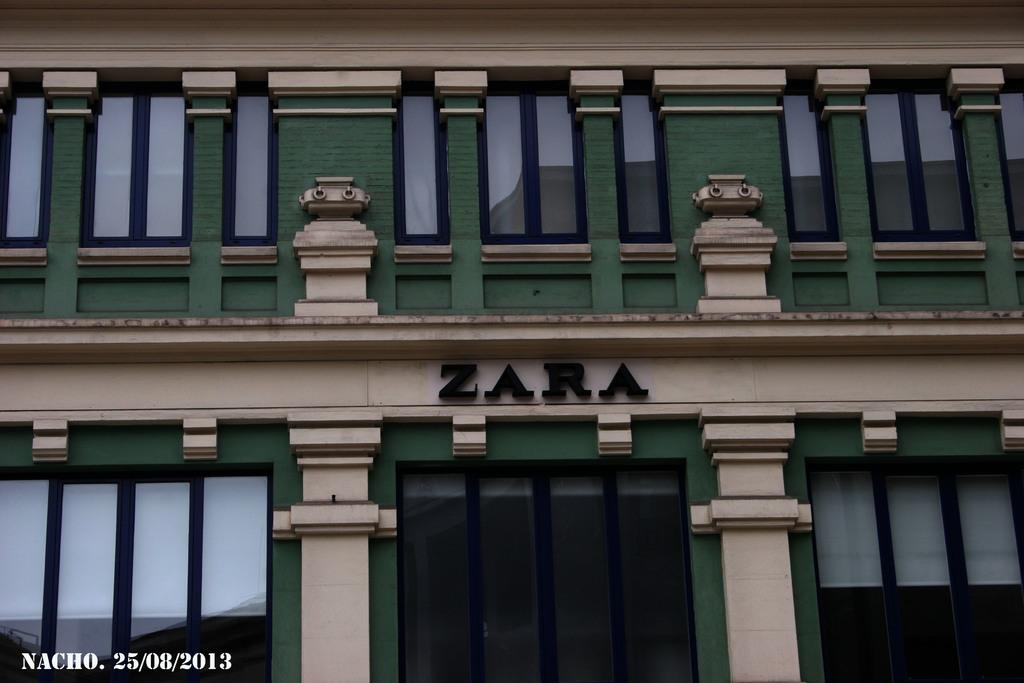What type of structure is partially visible in the image? There is a part of a building in the image. What architectural features can be seen on the building? The building has glass elements and pillared structures. What is written on the building? The name "ZARA" is visible on the building. How many pigs are visible on the building in the image? There are no pigs visible on the building in the image. What type of boundary surrounds the building in the image? The image does not show any boundaries surrounding the building. 